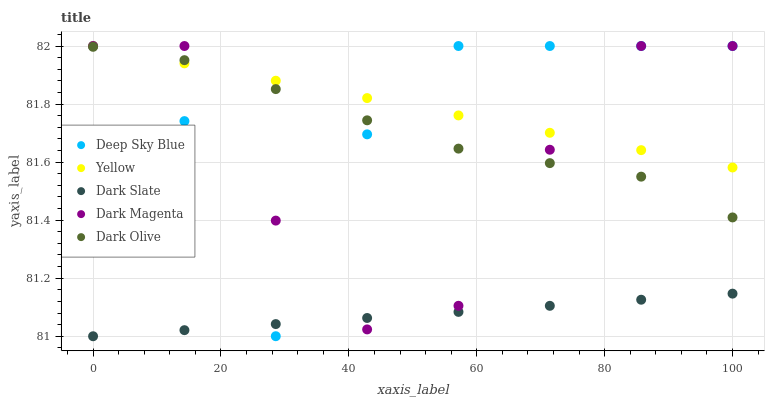Does Dark Slate have the minimum area under the curve?
Answer yes or no. Yes. Does Yellow have the maximum area under the curve?
Answer yes or no. Yes. Does Dark Olive have the minimum area under the curve?
Answer yes or no. No. Does Dark Olive have the maximum area under the curve?
Answer yes or no. No. Is Yellow the smoothest?
Answer yes or no. Yes. Is Deep Sky Blue the roughest?
Answer yes or no. Yes. Is Dark Olive the smoothest?
Answer yes or no. No. Is Dark Olive the roughest?
Answer yes or no. No. Does Dark Slate have the lowest value?
Answer yes or no. Yes. Does Dark Olive have the lowest value?
Answer yes or no. No. Does Dark Magenta have the highest value?
Answer yes or no. Yes. Does Dark Olive have the highest value?
Answer yes or no. No. Is Dark Slate less than Dark Olive?
Answer yes or no. Yes. Is Yellow greater than Dark Slate?
Answer yes or no. Yes. Does Dark Olive intersect Dark Magenta?
Answer yes or no. Yes. Is Dark Olive less than Dark Magenta?
Answer yes or no. No. Is Dark Olive greater than Dark Magenta?
Answer yes or no. No. Does Dark Slate intersect Dark Olive?
Answer yes or no. No. 